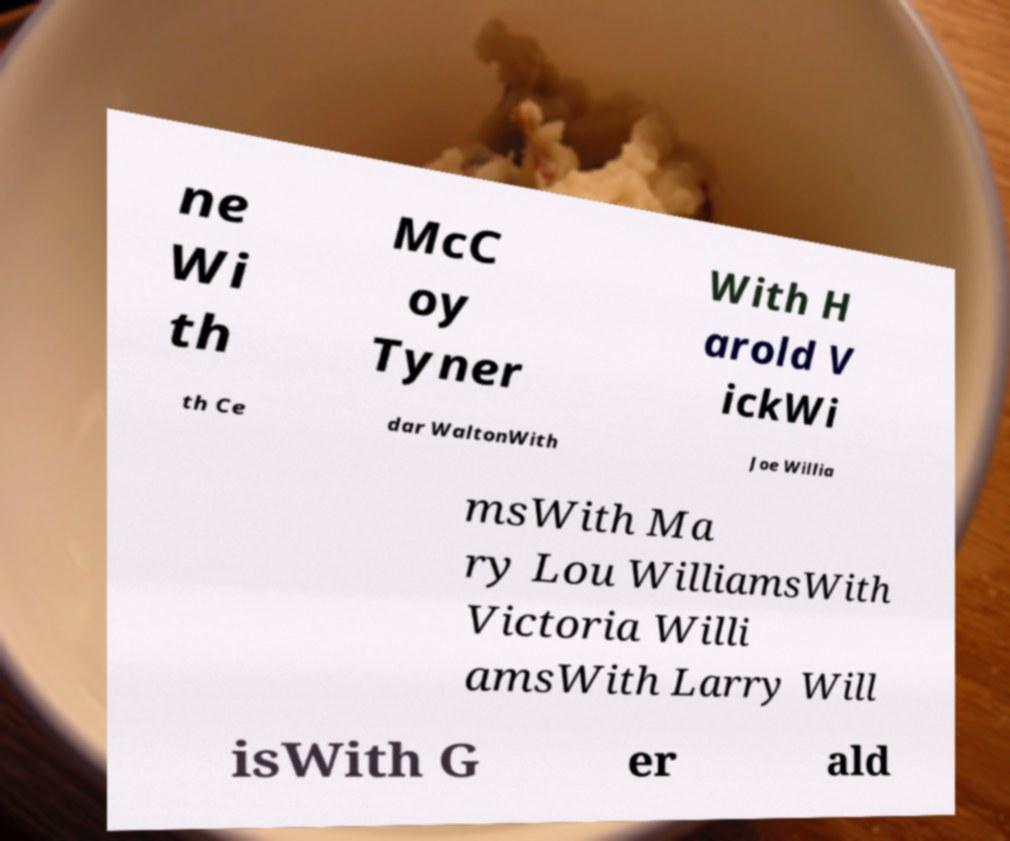Could you extract and type out the text from this image? ne Wi th McC oy Tyner With H arold V ickWi th Ce dar WaltonWith Joe Willia msWith Ma ry Lou WilliamsWith Victoria Willi amsWith Larry Will isWith G er ald 